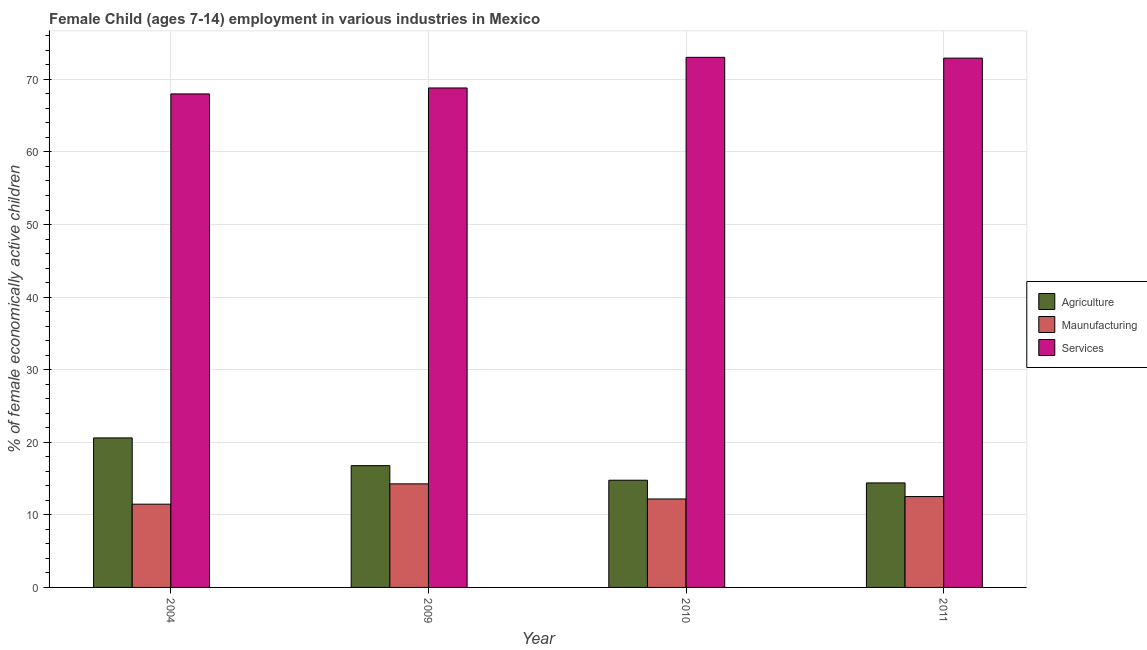How many different coloured bars are there?
Provide a succinct answer. 3. Are the number of bars on each tick of the X-axis equal?
Your answer should be compact. Yes. How many bars are there on the 2nd tick from the right?
Offer a terse response. 3. What is the label of the 1st group of bars from the left?
Provide a short and direct response. 2004. In how many cases, is the number of bars for a given year not equal to the number of legend labels?
Your answer should be compact. 0. What is the percentage of economically active children in agriculture in 2009?
Make the answer very short. 16.78. Across all years, what is the maximum percentage of economically active children in manufacturing?
Your answer should be compact. 14.27. In which year was the percentage of economically active children in manufacturing minimum?
Offer a terse response. 2004. What is the total percentage of economically active children in manufacturing in the graph?
Your response must be concise. 50.45. What is the difference between the percentage of economically active children in services in 2009 and that in 2010?
Ensure brevity in your answer.  -4.22. What is the difference between the percentage of economically active children in services in 2010 and the percentage of economically active children in agriculture in 2011?
Provide a short and direct response. 0.11. What is the average percentage of economically active children in agriculture per year?
Keep it short and to the point. 16.64. In how many years, is the percentage of economically active children in manufacturing greater than 42 %?
Offer a terse response. 0. What is the ratio of the percentage of economically active children in manufacturing in 2009 to that in 2011?
Your answer should be very brief. 1.14. Is the percentage of economically active children in services in 2010 less than that in 2011?
Provide a succinct answer. No. What is the difference between the highest and the lowest percentage of economically active children in agriculture?
Offer a very short reply. 6.2. What does the 2nd bar from the left in 2011 represents?
Ensure brevity in your answer.  Maunufacturing. What does the 2nd bar from the right in 2009 represents?
Offer a very short reply. Maunufacturing. Is it the case that in every year, the sum of the percentage of economically active children in agriculture and percentage of economically active children in manufacturing is greater than the percentage of economically active children in services?
Provide a succinct answer. No. Are the values on the major ticks of Y-axis written in scientific E-notation?
Your response must be concise. No. Does the graph contain any zero values?
Your response must be concise. No. How are the legend labels stacked?
Ensure brevity in your answer.  Vertical. What is the title of the graph?
Make the answer very short. Female Child (ages 7-14) employment in various industries in Mexico. What is the label or title of the Y-axis?
Make the answer very short. % of female economically active children. What is the % of female economically active children of Agriculture in 2004?
Ensure brevity in your answer.  20.6. What is the % of female economically active children in Maunufacturing in 2004?
Your answer should be very brief. 11.47. What is the % of female economically active children of Services in 2004?
Provide a short and direct response. 68. What is the % of female economically active children of Agriculture in 2009?
Your response must be concise. 16.78. What is the % of female economically active children of Maunufacturing in 2009?
Ensure brevity in your answer.  14.27. What is the % of female economically active children of Services in 2009?
Ensure brevity in your answer.  68.82. What is the % of female economically active children of Agriculture in 2010?
Give a very brief answer. 14.77. What is the % of female economically active children in Maunufacturing in 2010?
Your answer should be very brief. 12.19. What is the % of female economically active children of Services in 2010?
Make the answer very short. 73.04. What is the % of female economically active children in Agriculture in 2011?
Your answer should be compact. 14.4. What is the % of female economically active children in Maunufacturing in 2011?
Give a very brief answer. 12.52. What is the % of female economically active children of Services in 2011?
Provide a short and direct response. 72.93. Across all years, what is the maximum % of female economically active children of Agriculture?
Give a very brief answer. 20.6. Across all years, what is the maximum % of female economically active children of Maunufacturing?
Offer a very short reply. 14.27. Across all years, what is the maximum % of female economically active children in Services?
Make the answer very short. 73.04. Across all years, what is the minimum % of female economically active children of Maunufacturing?
Give a very brief answer. 11.47. Across all years, what is the minimum % of female economically active children of Services?
Provide a succinct answer. 68. What is the total % of female economically active children of Agriculture in the graph?
Your answer should be compact. 66.55. What is the total % of female economically active children of Maunufacturing in the graph?
Make the answer very short. 50.45. What is the total % of female economically active children of Services in the graph?
Offer a very short reply. 282.79. What is the difference between the % of female economically active children of Agriculture in 2004 and that in 2009?
Your answer should be very brief. 3.82. What is the difference between the % of female economically active children in Services in 2004 and that in 2009?
Your answer should be compact. -0.82. What is the difference between the % of female economically active children of Agriculture in 2004 and that in 2010?
Make the answer very short. 5.83. What is the difference between the % of female economically active children of Maunufacturing in 2004 and that in 2010?
Offer a very short reply. -0.72. What is the difference between the % of female economically active children of Services in 2004 and that in 2010?
Your answer should be very brief. -5.04. What is the difference between the % of female economically active children of Agriculture in 2004 and that in 2011?
Keep it short and to the point. 6.2. What is the difference between the % of female economically active children of Maunufacturing in 2004 and that in 2011?
Your answer should be compact. -1.05. What is the difference between the % of female economically active children in Services in 2004 and that in 2011?
Offer a very short reply. -4.93. What is the difference between the % of female economically active children in Agriculture in 2009 and that in 2010?
Provide a short and direct response. 2.01. What is the difference between the % of female economically active children in Maunufacturing in 2009 and that in 2010?
Make the answer very short. 2.08. What is the difference between the % of female economically active children in Services in 2009 and that in 2010?
Your response must be concise. -4.22. What is the difference between the % of female economically active children in Agriculture in 2009 and that in 2011?
Ensure brevity in your answer.  2.38. What is the difference between the % of female economically active children of Maunufacturing in 2009 and that in 2011?
Your answer should be very brief. 1.75. What is the difference between the % of female economically active children in Services in 2009 and that in 2011?
Offer a terse response. -4.11. What is the difference between the % of female economically active children in Agriculture in 2010 and that in 2011?
Make the answer very short. 0.37. What is the difference between the % of female economically active children in Maunufacturing in 2010 and that in 2011?
Provide a succinct answer. -0.33. What is the difference between the % of female economically active children of Services in 2010 and that in 2011?
Give a very brief answer. 0.11. What is the difference between the % of female economically active children in Agriculture in 2004 and the % of female economically active children in Maunufacturing in 2009?
Offer a very short reply. 6.33. What is the difference between the % of female economically active children in Agriculture in 2004 and the % of female economically active children in Services in 2009?
Your answer should be compact. -48.22. What is the difference between the % of female economically active children of Maunufacturing in 2004 and the % of female economically active children of Services in 2009?
Make the answer very short. -57.35. What is the difference between the % of female economically active children in Agriculture in 2004 and the % of female economically active children in Maunufacturing in 2010?
Offer a very short reply. 8.41. What is the difference between the % of female economically active children in Agriculture in 2004 and the % of female economically active children in Services in 2010?
Provide a short and direct response. -52.44. What is the difference between the % of female economically active children in Maunufacturing in 2004 and the % of female economically active children in Services in 2010?
Provide a short and direct response. -61.57. What is the difference between the % of female economically active children in Agriculture in 2004 and the % of female economically active children in Maunufacturing in 2011?
Your response must be concise. 8.08. What is the difference between the % of female economically active children of Agriculture in 2004 and the % of female economically active children of Services in 2011?
Ensure brevity in your answer.  -52.33. What is the difference between the % of female economically active children in Maunufacturing in 2004 and the % of female economically active children in Services in 2011?
Your answer should be very brief. -61.46. What is the difference between the % of female economically active children of Agriculture in 2009 and the % of female economically active children of Maunufacturing in 2010?
Keep it short and to the point. 4.59. What is the difference between the % of female economically active children of Agriculture in 2009 and the % of female economically active children of Services in 2010?
Offer a very short reply. -56.26. What is the difference between the % of female economically active children of Maunufacturing in 2009 and the % of female economically active children of Services in 2010?
Give a very brief answer. -58.77. What is the difference between the % of female economically active children in Agriculture in 2009 and the % of female economically active children in Maunufacturing in 2011?
Offer a very short reply. 4.26. What is the difference between the % of female economically active children in Agriculture in 2009 and the % of female economically active children in Services in 2011?
Your answer should be very brief. -56.15. What is the difference between the % of female economically active children in Maunufacturing in 2009 and the % of female economically active children in Services in 2011?
Offer a terse response. -58.66. What is the difference between the % of female economically active children in Agriculture in 2010 and the % of female economically active children in Maunufacturing in 2011?
Provide a short and direct response. 2.25. What is the difference between the % of female economically active children in Agriculture in 2010 and the % of female economically active children in Services in 2011?
Ensure brevity in your answer.  -58.16. What is the difference between the % of female economically active children in Maunufacturing in 2010 and the % of female economically active children in Services in 2011?
Give a very brief answer. -60.74. What is the average % of female economically active children in Agriculture per year?
Keep it short and to the point. 16.64. What is the average % of female economically active children in Maunufacturing per year?
Provide a short and direct response. 12.61. What is the average % of female economically active children of Services per year?
Keep it short and to the point. 70.7. In the year 2004, what is the difference between the % of female economically active children in Agriculture and % of female economically active children in Maunufacturing?
Provide a short and direct response. 9.13. In the year 2004, what is the difference between the % of female economically active children of Agriculture and % of female economically active children of Services?
Keep it short and to the point. -47.4. In the year 2004, what is the difference between the % of female economically active children in Maunufacturing and % of female economically active children in Services?
Give a very brief answer. -56.53. In the year 2009, what is the difference between the % of female economically active children of Agriculture and % of female economically active children of Maunufacturing?
Offer a terse response. 2.51. In the year 2009, what is the difference between the % of female economically active children in Agriculture and % of female economically active children in Services?
Offer a terse response. -52.04. In the year 2009, what is the difference between the % of female economically active children in Maunufacturing and % of female economically active children in Services?
Offer a very short reply. -54.55. In the year 2010, what is the difference between the % of female economically active children in Agriculture and % of female economically active children in Maunufacturing?
Keep it short and to the point. 2.58. In the year 2010, what is the difference between the % of female economically active children of Agriculture and % of female economically active children of Services?
Ensure brevity in your answer.  -58.27. In the year 2010, what is the difference between the % of female economically active children in Maunufacturing and % of female economically active children in Services?
Make the answer very short. -60.85. In the year 2011, what is the difference between the % of female economically active children of Agriculture and % of female economically active children of Maunufacturing?
Provide a short and direct response. 1.88. In the year 2011, what is the difference between the % of female economically active children of Agriculture and % of female economically active children of Services?
Offer a terse response. -58.53. In the year 2011, what is the difference between the % of female economically active children in Maunufacturing and % of female economically active children in Services?
Your answer should be compact. -60.41. What is the ratio of the % of female economically active children of Agriculture in 2004 to that in 2009?
Your response must be concise. 1.23. What is the ratio of the % of female economically active children in Maunufacturing in 2004 to that in 2009?
Give a very brief answer. 0.8. What is the ratio of the % of female economically active children of Services in 2004 to that in 2009?
Keep it short and to the point. 0.99. What is the ratio of the % of female economically active children in Agriculture in 2004 to that in 2010?
Your answer should be very brief. 1.39. What is the ratio of the % of female economically active children of Maunufacturing in 2004 to that in 2010?
Offer a very short reply. 0.94. What is the ratio of the % of female economically active children of Agriculture in 2004 to that in 2011?
Offer a very short reply. 1.43. What is the ratio of the % of female economically active children of Maunufacturing in 2004 to that in 2011?
Provide a short and direct response. 0.92. What is the ratio of the % of female economically active children in Services in 2004 to that in 2011?
Provide a succinct answer. 0.93. What is the ratio of the % of female economically active children of Agriculture in 2009 to that in 2010?
Ensure brevity in your answer.  1.14. What is the ratio of the % of female economically active children in Maunufacturing in 2009 to that in 2010?
Offer a very short reply. 1.17. What is the ratio of the % of female economically active children in Services in 2009 to that in 2010?
Give a very brief answer. 0.94. What is the ratio of the % of female economically active children in Agriculture in 2009 to that in 2011?
Keep it short and to the point. 1.17. What is the ratio of the % of female economically active children in Maunufacturing in 2009 to that in 2011?
Your response must be concise. 1.14. What is the ratio of the % of female economically active children of Services in 2009 to that in 2011?
Offer a very short reply. 0.94. What is the ratio of the % of female economically active children in Agriculture in 2010 to that in 2011?
Your answer should be compact. 1.03. What is the ratio of the % of female economically active children in Maunufacturing in 2010 to that in 2011?
Offer a very short reply. 0.97. What is the difference between the highest and the second highest % of female economically active children of Agriculture?
Keep it short and to the point. 3.82. What is the difference between the highest and the second highest % of female economically active children of Maunufacturing?
Ensure brevity in your answer.  1.75. What is the difference between the highest and the second highest % of female economically active children of Services?
Make the answer very short. 0.11. What is the difference between the highest and the lowest % of female economically active children of Agriculture?
Provide a short and direct response. 6.2. What is the difference between the highest and the lowest % of female economically active children in Services?
Ensure brevity in your answer.  5.04. 